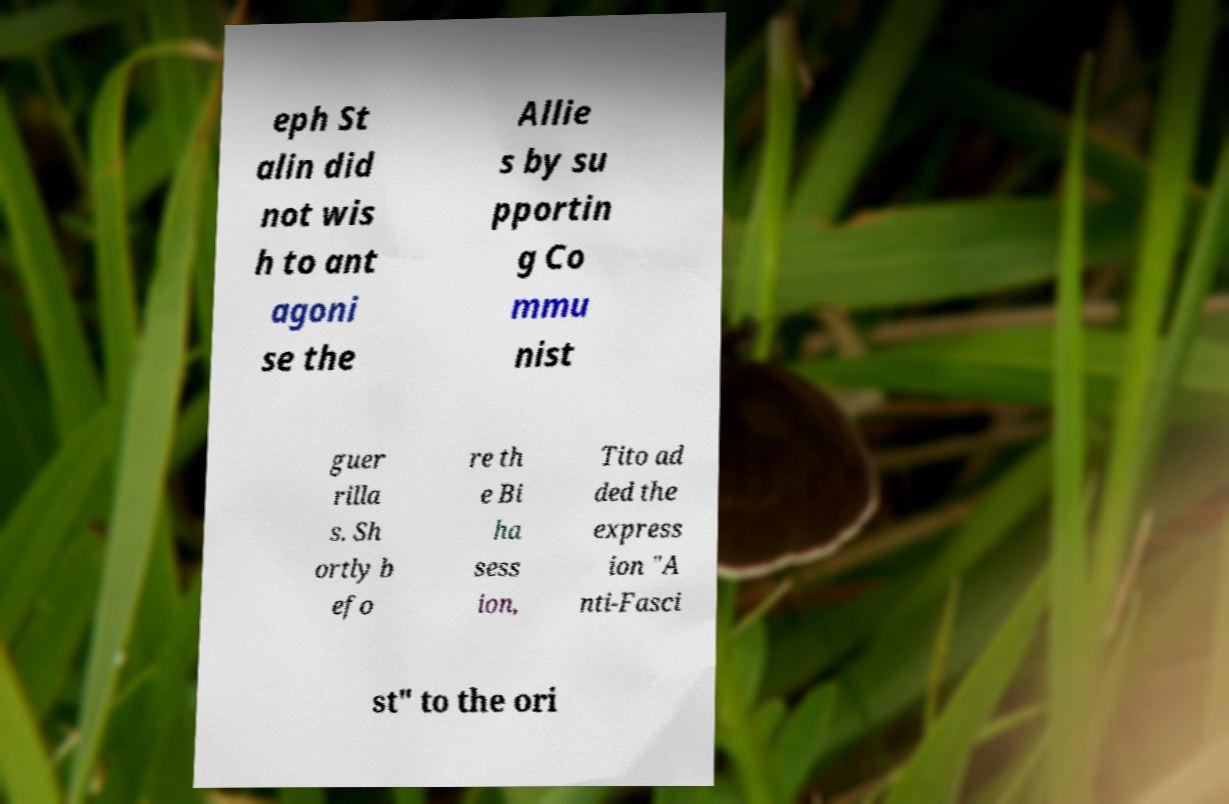Can you read and provide the text displayed in the image?This photo seems to have some interesting text. Can you extract and type it out for me? eph St alin did not wis h to ant agoni se the Allie s by su pportin g Co mmu nist guer rilla s. Sh ortly b efo re th e Bi ha sess ion, Tito ad ded the express ion "A nti-Fasci st" to the ori 